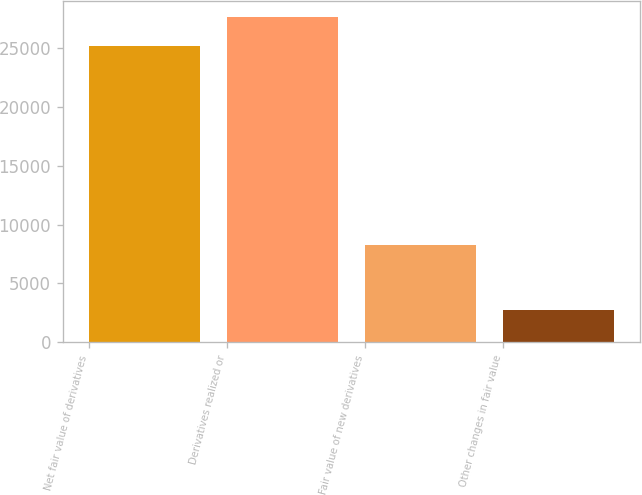Convert chart. <chart><loc_0><loc_0><loc_500><loc_500><bar_chart><fcel>Net fair value of derivatives<fcel>Derivatives realized or<fcel>Fair value of new derivatives<fcel>Other changes in fair value<nl><fcel>25171<fcel>27619.5<fcel>8287<fcel>2766<nl></chart> 